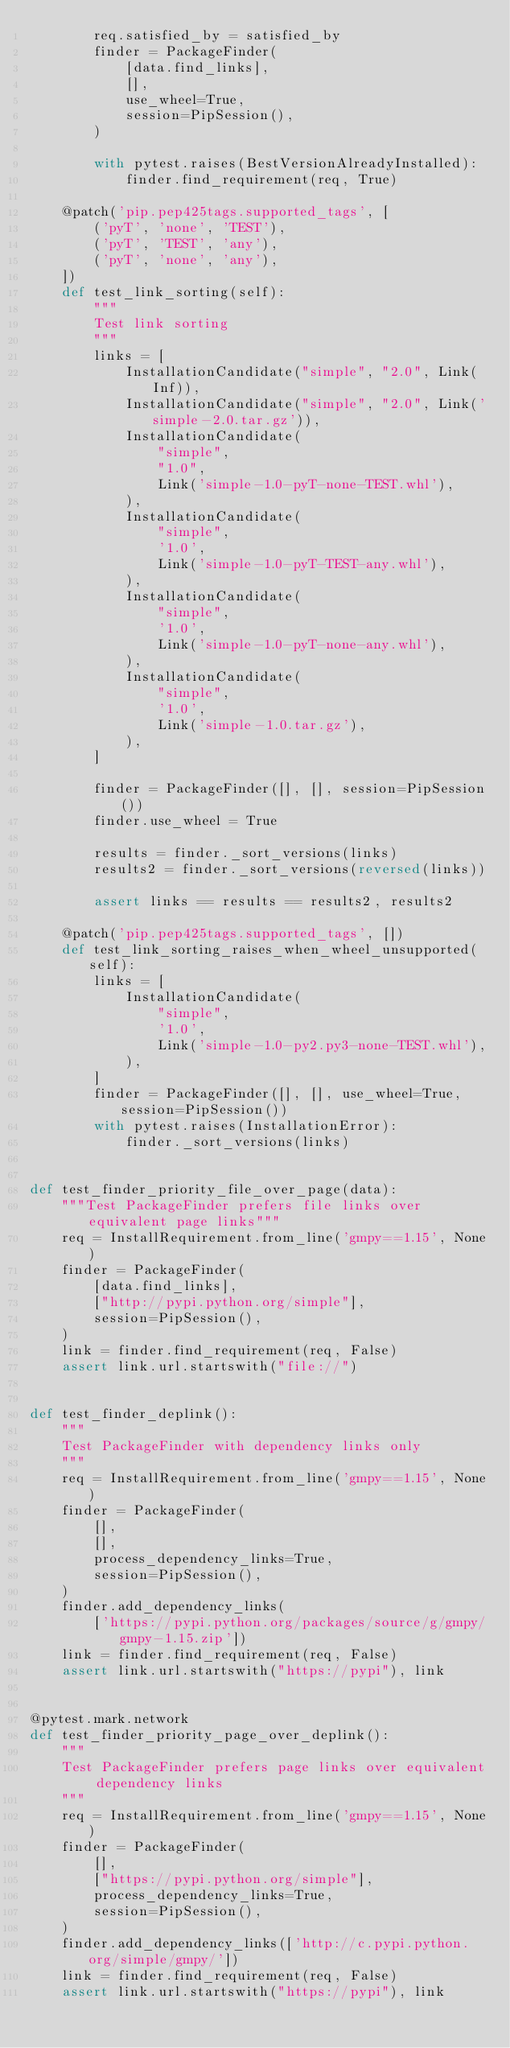<code> <loc_0><loc_0><loc_500><loc_500><_Python_>        req.satisfied_by = satisfied_by
        finder = PackageFinder(
            [data.find_links],
            [],
            use_wheel=True,
            session=PipSession(),
        )

        with pytest.raises(BestVersionAlreadyInstalled):
            finder.find_requirement(req, True)

    @patch('pip.pep425tags.supported_tags', [
        ('pyT', 'none', 'TEST'),
        ('pyT', 'TEST', 'any'),
        ('pyT', 'none', 'any'),
    ])
    def test_link_sorting(self):
        """
        Test link sorting
        """
        links = [
            InstallationCandidate("simple", "2.0", Link(Inf)),
            InstallationCandidate("simple", "2.0", Link('simple-2.0.tar.gz')),
            InstallationCandidate(
                "simple",
                "1.0",
                Link('simple-1.0-pyT-none-TEST.whl'),
            ),
            InstallationCandidate(
                "simple",
                '1.0',
                Link('simple-1.0-pyT-TEST-any.whl'),
            ),
            InstallationCandidate(
                "simple",
                '1.0',
                Link('simple-1.0-pyT-none-any.whl'),
            ),
            InstallationCandidate(
                "simple",
                '1.0',
                Link('simple-1.0.tar.gz'),
            ),
        ]

        finder = PackageFinder([], [], session=PipSession())
        finder.use_wheel = True

        results = finder._sort_versions(links)
        results2 = finder._sort_versions(reversed(links))

        assert links == results == results2, results2

    @patch('pip.pep425tags.supported_tags', [])
    def test_link_sorting_raises_when_wheel_unsupported(self):
        links = [
            InstallationCandidate(
                "simple",
                '1.0',
                Link('simple-1.0-py2.py3-none-TEST.whl'),
            ),
        ]
        finder = PackageFinder([], [], use_wheel=True, session=PipSession())
        with pytest.raises(InstallationError):
            finder._sort_versions(links)


def test_finder_priority_file_over_page(data):
    """Test PackageFinder prefers file links over equivalent page links"""
    req = InstallRequirement.from_line('gmpy==1.15', None)
    finder = PackageFinder(
        [data.find_links],
        ["http://pypi.python.org/simple"],
        session=PipSession(),
    )
    link = finder.find_requirement(req, False)
    assert link.url.startswith("file://")


def test_finder_deplink():
    """
    Test PackageFinder with dependency links only
    """
    req = InstallRequirement.from_line('gmpy==1.15', None)
    finder = PackageFinder(
        [],
        [],
        process_dependency_links=True,
        session=PipSession(),
    )
    finder.add_dependency_links(
        ['https://pypi.python.org/packages/source/g/gmpy/gmpy-1.15.zip'])
    link = finder.find_requirement(req, False)
    assert link.url.startswith("https://pypi"), link


@pytest.mark.network
def test_finder_priority_page_over_deplink():
    """
    Test PackageFinder prefers page links over equivalent dependency links
    """
    req = InstallRequirement.from_line('gmpy==1.15', None)
    finder = PackageFinder(
        [],
        ["https://pypi.python.org/simple"],
        process_dependency_links=True,
        session=PipSession(),
    )
    finder.add_dependency_links(['http://c.pypi.python.org/simple/gmpy/'])
    link = finder.find_requirement(req, False)
    assert link.url.startswith("https://pypi"), link

</code> 